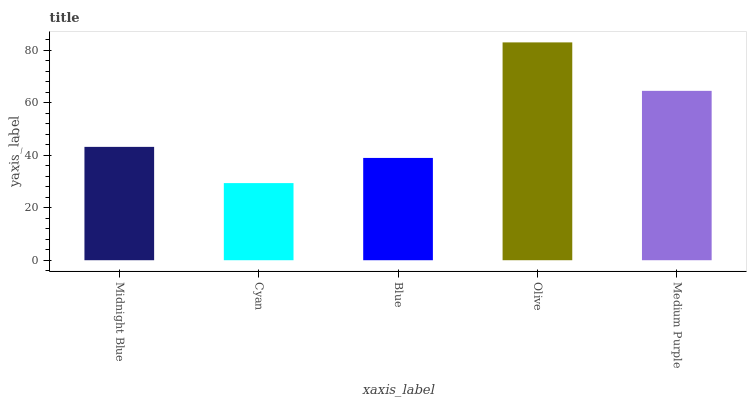Is Blue the minimum?
Answer yes or no. No. Is Blue the maximum?
Answer yes or no. No. Is Blue greater than Cyan?
Answer yes or no. Yes. Is Cyan less than Blue?
Answer yes or no. Yes. Is Cyan greater than Blue?
Answer yes or no. No. Is Blue less than Cyan?
Answer yes or no. No. Is Midnight Blue the high median?
Answer yes or no. Yes. Is Midnight Blue the low median?
Answer yes or no. Yes. Is Olive the high median?
Answer yes or no. No. Is Olive the low median?
Answer yes or no. No. 